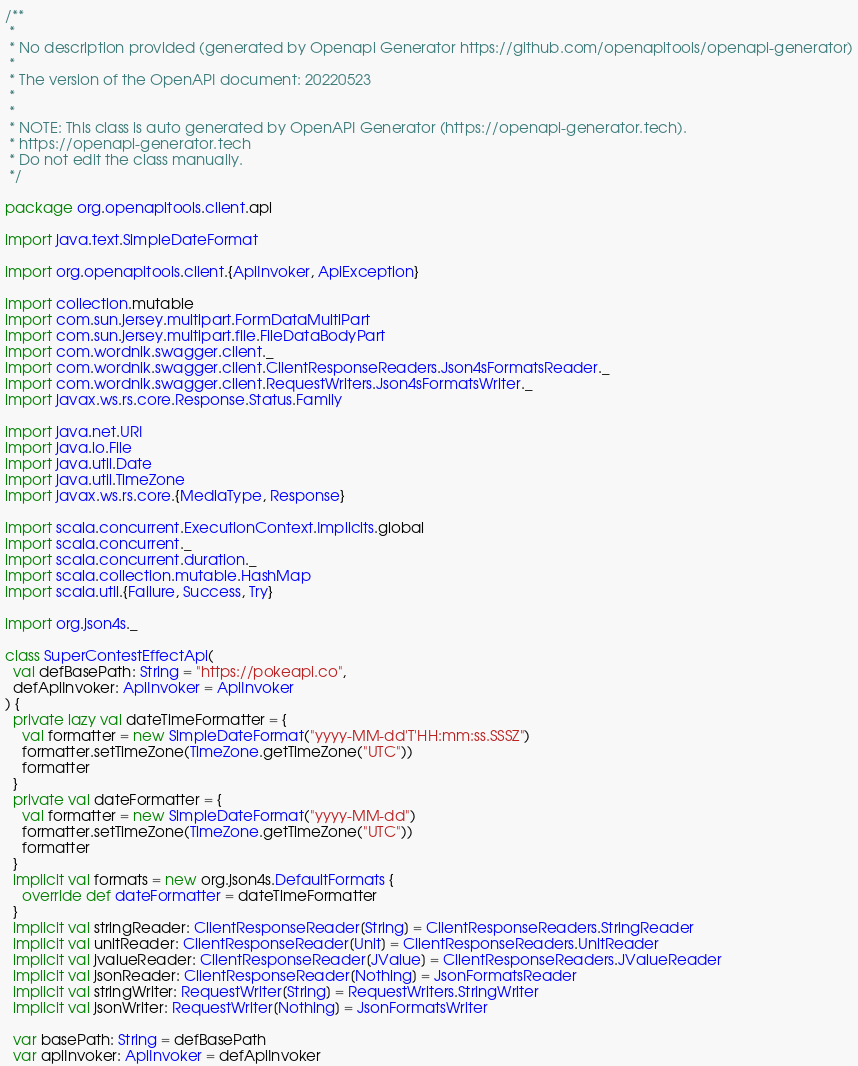Convert code to text. <code><loc_0><loc_0><loc_500><loc_500><_Scala_>/**
 * 
 * No description provided (generated by Openapi Generator https://github.com/openapitools/openapi-generator)
 *
 * The version of the OpenAPI document: 20220523
 * 
 *
 * NOTE: This class is auto generated by OpenAPI Generator (https://openapi-generator.tech).
 * https://openapi-generator.tech
 * Do not edit the class manually.
 */

package org.openapitools.client.api

import java.text.SimpleDateFormat

import org.openapitools.client.{ApiInvoker, ApiException}

import collection.mutable
import com.sun.jersey.multipart.FormDataMultiPart
import com.sun.jersey.multipart.file.FileDataBodyPart
import com.wordnik.swagger.client._
import com.wordnik.swagger.client.ClientResponseReaders.Json4sFormatsReader._
import com.wordnik.swagger.client.RequestWriters.Json4sFormatsWriter._
import javax.ws.rs.core.Response.Status.Family

import java.net.URI
import java.io.File
import java.util.Date
import java.util.TimeZone
import javax.ws.rs.core.{MediaType, Response}

import scala.concurrent.ExecutionContext.Implicits.global
import scala.concurrent._
import scala.concurrent.duration._
import scala.collection.mutable.HashMap
import scala.util.{Failure, Success, Try}

import org.json4s._

class SuperContestEffectApi(
  val defBasePath: String = "https://pokeapi.co",
  defApiInvoker: ApiInvoker = ApiInvoker
) {
  private lazy val dateTimeFormatter = {
    val formatter = new SimpleDateFormat("yyyy-MM-dd'T'HH:mm:ss.SSSZ")
    formatter.setTimeZone(TimeZone.getTimeZone("UTC"))
    formatter
  }
  private val dateFormatter = {
    val formatter = new SimpleDateFormat("yyyy-MM-dd")
    formatter.setTimeZone(TimeZone.getTimeZone("UTC"))
    formatter
  }
  implicit val formats = new org.json4s.DefaultFormats {
    override def dateFormatter = dateTimeFormatter
  }
  implicit val stringReader: ClientResponseReader[String] = ClientResponseReaders.StringReader
  implicit val unitReader: ClientResponseReader[Unit] = ClientResponseReaders.UnitReader
  implicit val jvalueReader: ClientResponseReader[JValue] = ClientResponseReaders.JValueReader
  implicit val jsonReader: ClientResponseReader[Nothing] = JsonFormatsReader
  implicit val stringWriter: RequestWriter[String] = RequestWriters.StringWriter
  implicit val jsonWriter: RequestWriter[Nothing] = JsonFormatsWriter

  var basePath: String = defBasePath
  var apiInvoker: ApiInvoker = defApiInvoker
</code> 